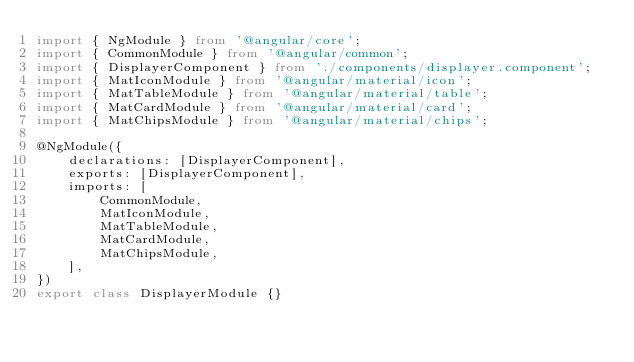<code> <loc_0><loc_0><loc_500><loc_500><_TypeScript_>import { NgModule } from '@angular/core';
import { CommonModule } from '@angular/common';
import { DisplayerComponent } from './components/displayer.component';
import { MatIconModule } from '@angular/material/icon';
import { MatTableModule } from '@angular/material/table';
import { MatCardModule } from '@angular/material/card';
import { MatChipsModule } from '@angular/material/chips';

@NgModule({
    declarations: [DisplayerComponent],
    exports: [DisplayerComponent],
    imports: [
        CommonModule,
        MatIconModule,
        MatTableModule,
        MatCardModule,
        MatChipsModule,
    ],
})
export class DisplayerModule {}
</code> 